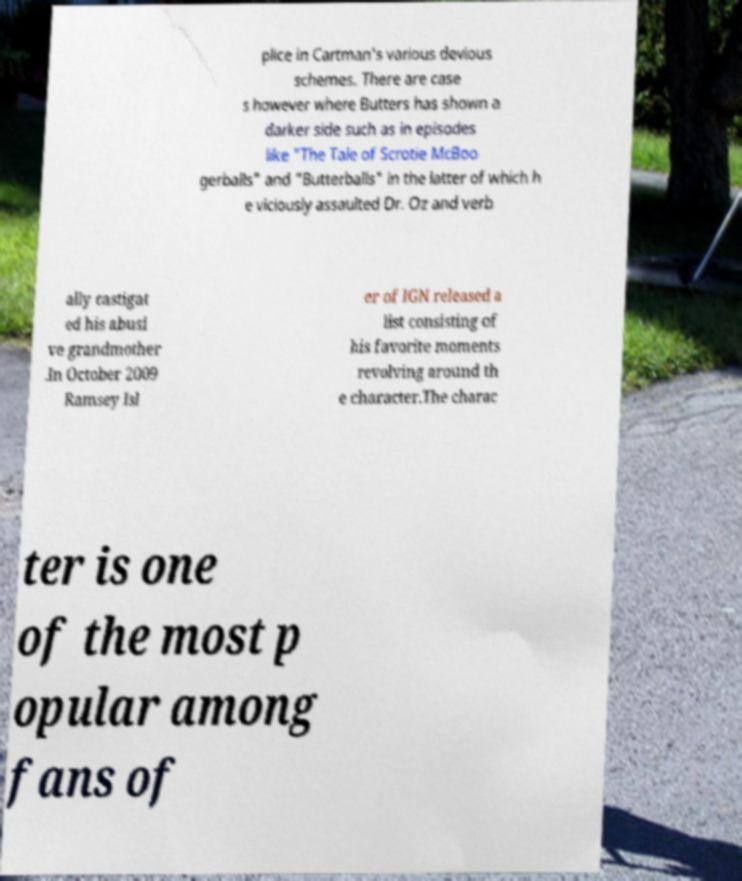Please read and relay the text visible in this image. What does it say? plice in Cartman's various devious schemes. There are case s however where Butters has shown a darker side such as in episodes like "The Tale of Scrotie McBoo gerballs" and "Butterballs" in the latter of which h e viciously assaulted Dr. Oz and verb ally castigat ed his abusi ve grandmother .In October 2009 Ramsey Isl er of IGN released a list consisting of his favorite moments revolving around th e character.The charac ter is one of the most p opular among fans of 